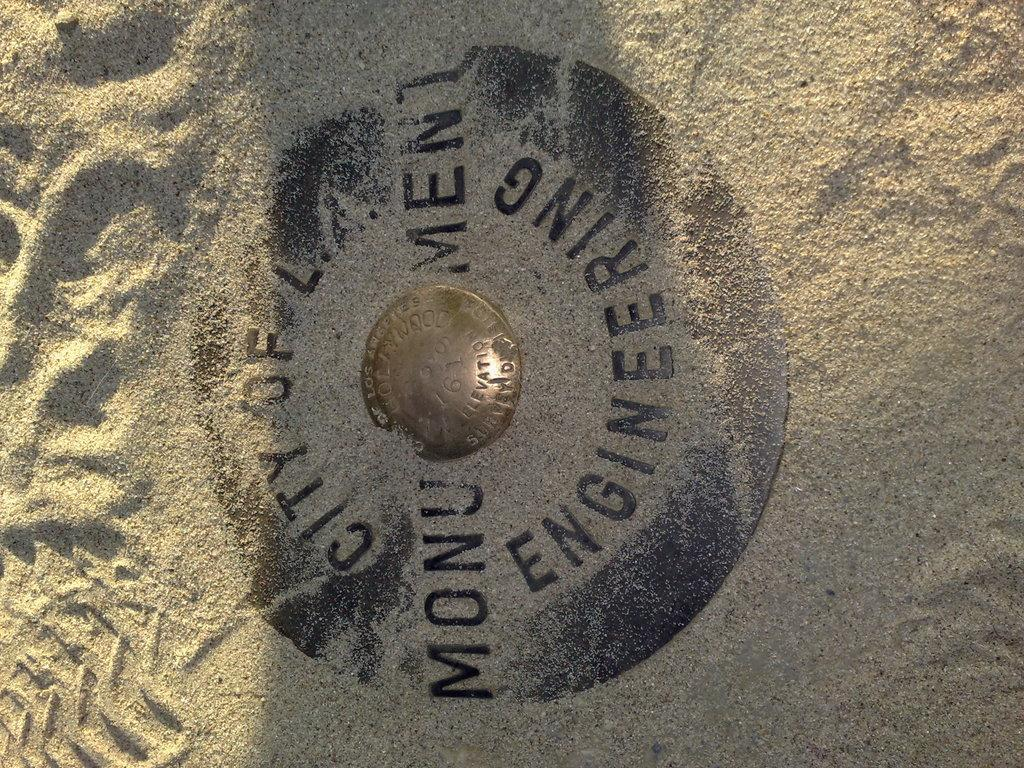<image>
Give a short and clear explanation of the subsequent image. a manhole reading City of LA in the middle of sand 